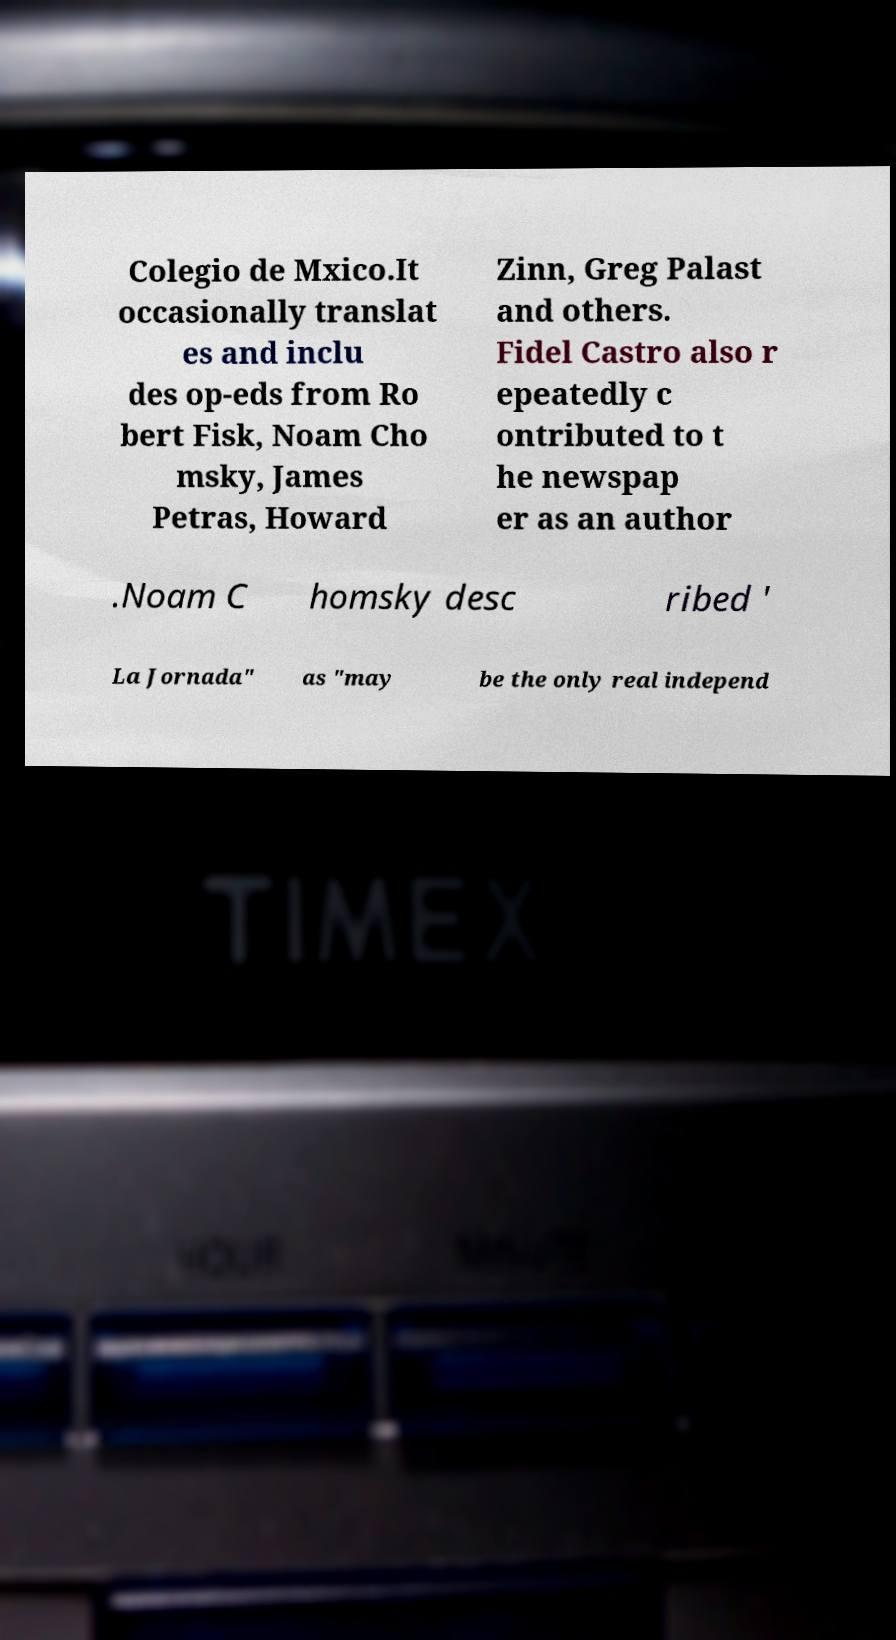Please read and relay the text visible in this image. What does it say? Colegio de Mxico.It occasionally translat es and inclu des op-eds from Ro bert Fisk, Noam Cho msky, James Petras, Howard Zinn, Greg Palast and others. Fidel Castro also r epeatedly c ontributed to t he newspap er as an author .Noam C homsky desc ribed ' La Jornada" as "may be the only real independ 